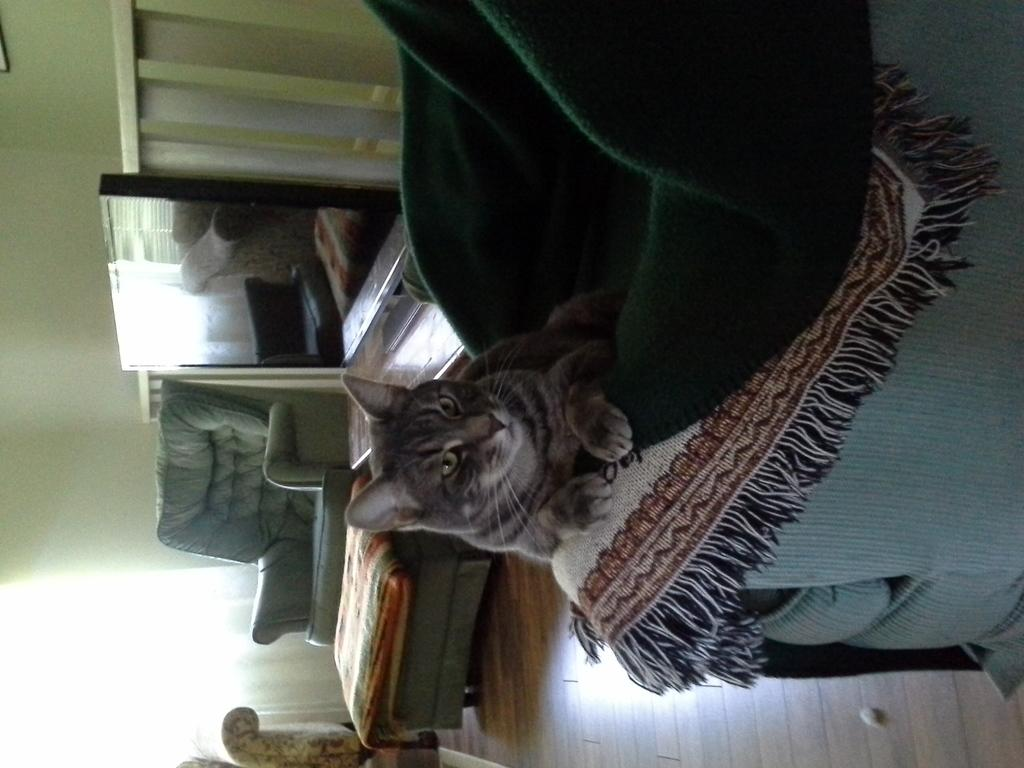What animal can be seen on the bed in the image? There is a cat on the bed in the image. What type of furniture is present in the image? There are sofas and a table in the image. What is the purpose of the screen in the image? The purpose of the screen is not specified in the image, but it could be a TV or computer screen. How many waves can be seen in the image? There are no waves present in the image. What type of salt is used to season the cat in the image? There is no salt or seasoning mentioned in the image, and the cat is not being prepared as food. 